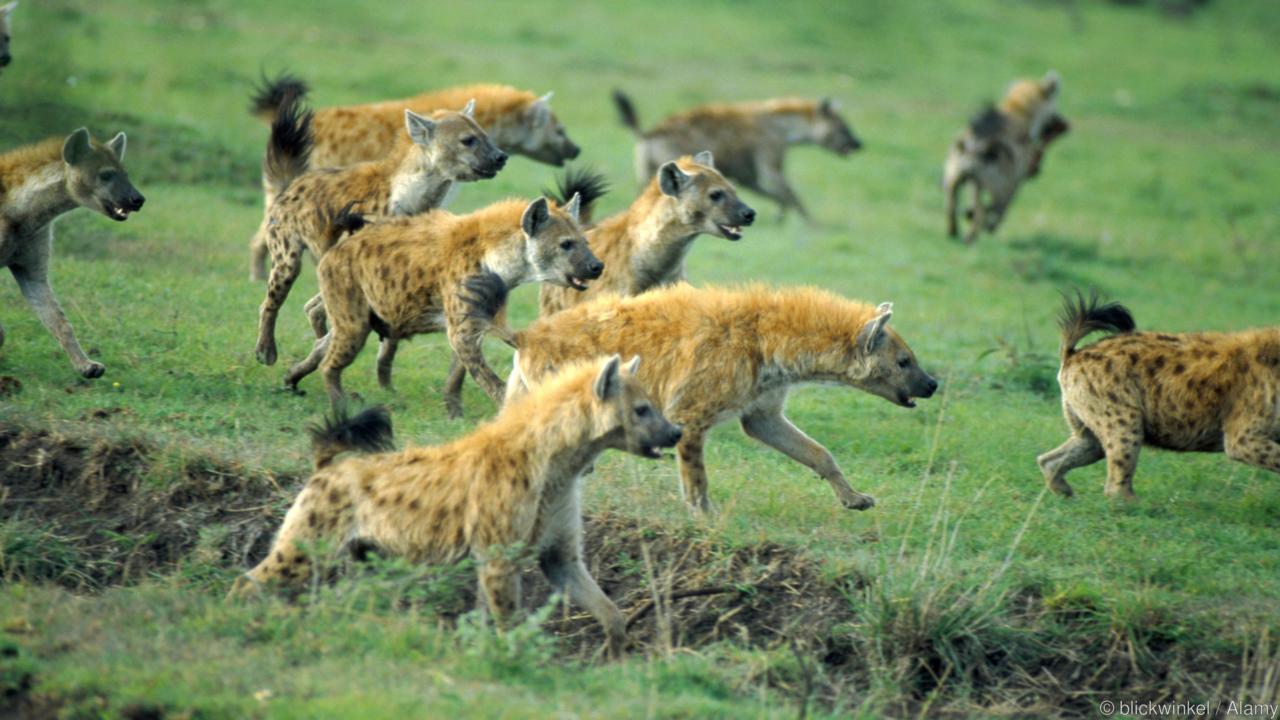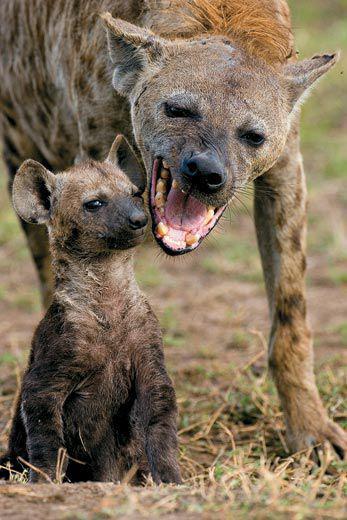The first image is the image on the left, the second image is the image on the right. For the images displayed, is the sentence "There are at most 4 hyenas." factually correct? Answer yes or no. No. The first image is the image on the left, the second image is the image on the right. Considering the images on both sides, is "The image on the left has one hyena that is facing towards the right." valid? Answer yes or no. No. 